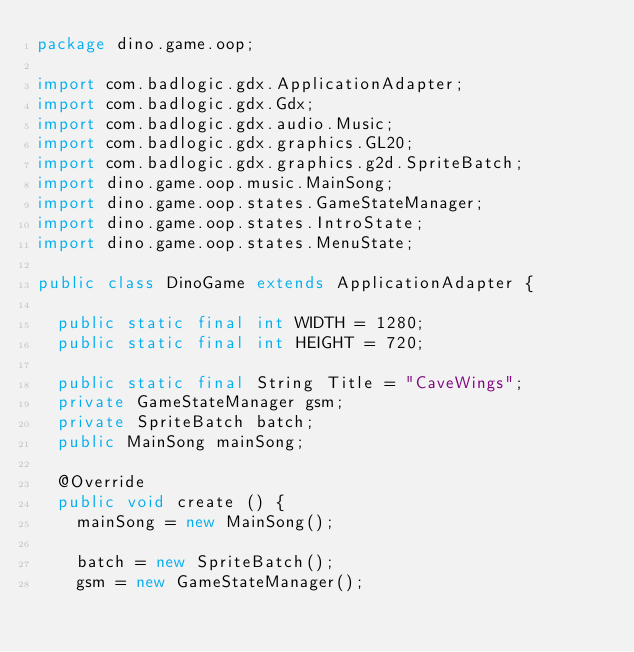<code> <loc_0><loc_0><loc_500><loc_500><_Java_>package dino.game.oop;

import com.badlogic.gdx.ApplicationAdapter;
import com.badlogic.gdx.Gdx;
import com.badlogic.gdx.audio.Music;
import com.badlogic.gdx.graphics.GL20;
import com.badlogic.gdx.graphics.g2d.SpriteBatch;
import dino.game.oop.music.MainSong;
import dino.game.oop.states.GameStateManager;
import dino.game.oop.states.IntroState;
import dino.game.oop.states.MenuState;

public class DinoGame extends ApplicationAdapter {

	public static final int WIDTH = 1280;
	public static final int HEIGHT = 720;

	public static final String Title = "CaveWings";
	private GameStateManager gsm;
	private SpriteBatch batch;
	public MainSong mainSong;

	@Override
	public void create () {
		mainSong = new MainSong();

		batch = new SpriteBatch();
		gsm = new GameStateManager();</code> 